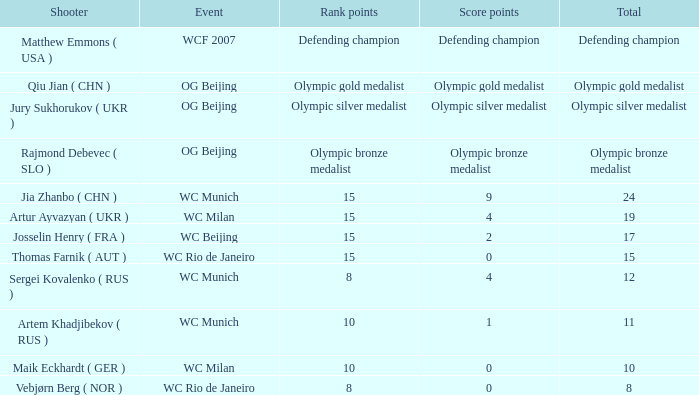With olympic bronze medalist as the aggregate, what are the points earned? Olympic bronze medalist. 